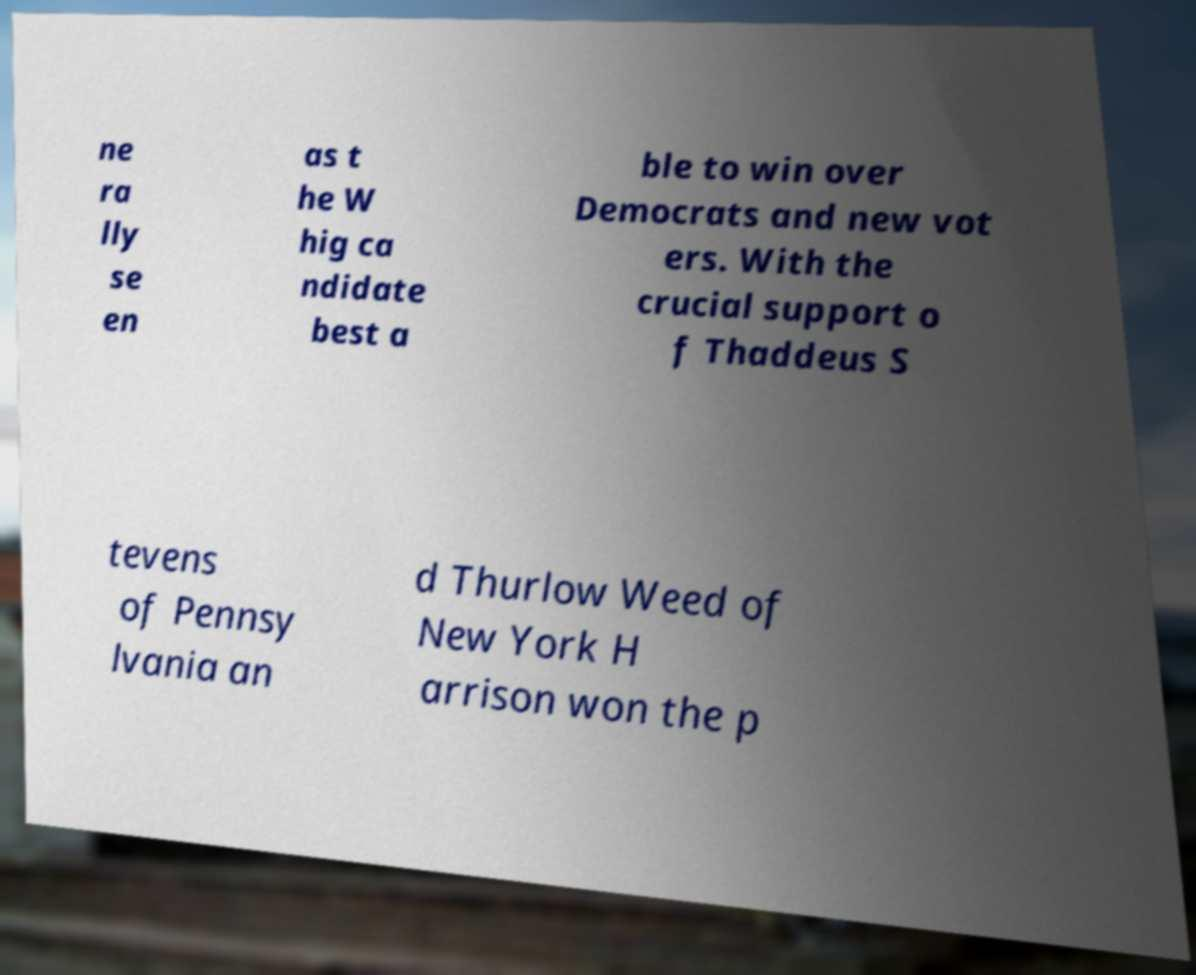Could you extract and type out the text from this image? ne ra lly se en as t he W hig ca ndidate best a ble to win over Democrats and new vot ers. With the crucial support o f Thaddeus S tevens of Pennsy lvania an d Thurlow Weed of New York H arrison won the p 